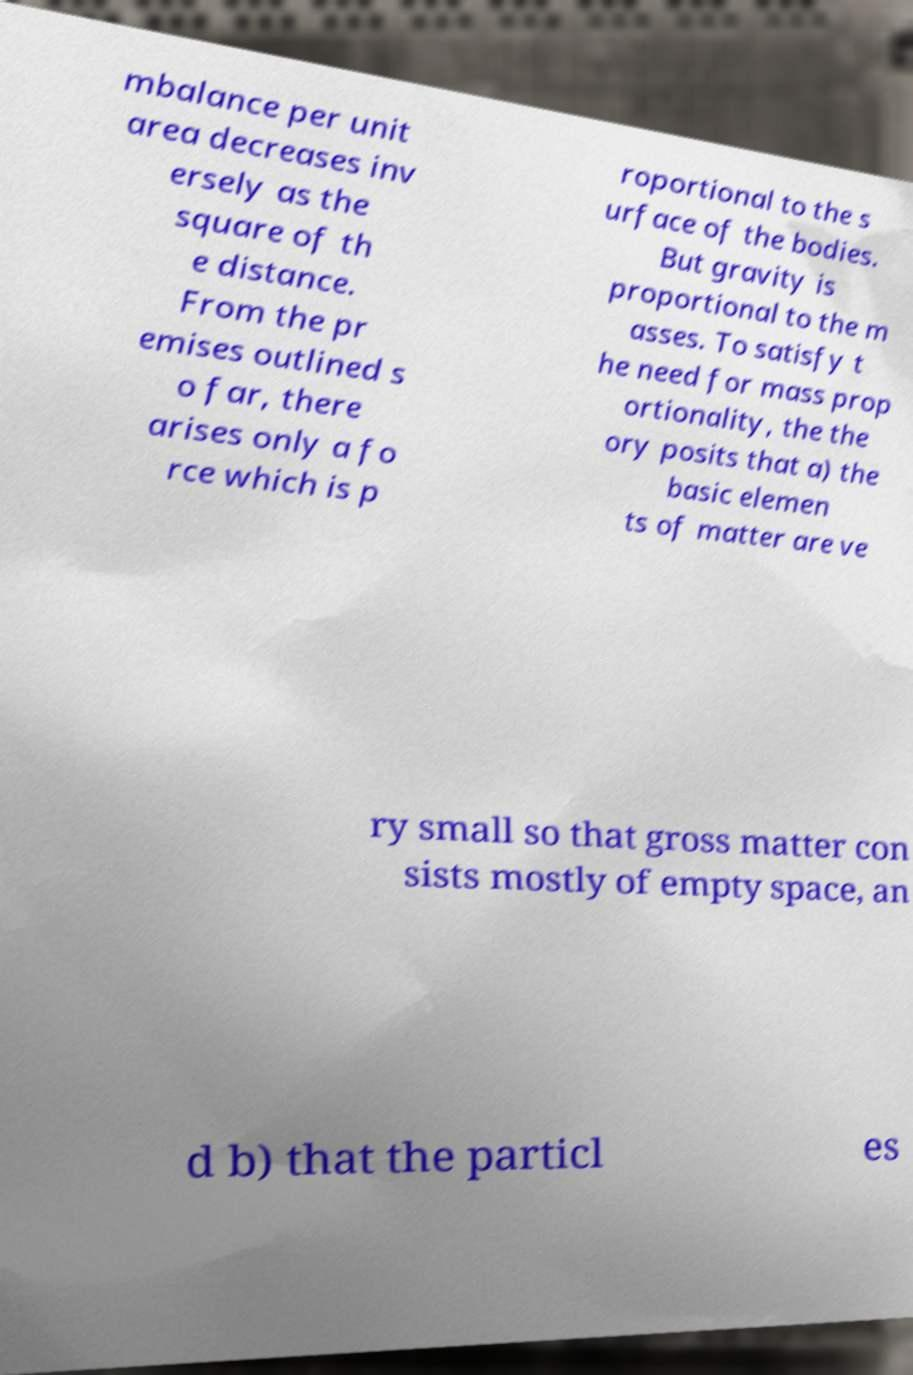What messages or text are displayed in this image? I need them in a readable, typed format. mbalance per unit area decreases inv ersely as the square of th e distance. From the pr emises outlined s o far, there arises only a fo rce which is p roportional to the s urface of the bodies. But gravity is proportional to the m asses. To satisfy t he need for mass prop ortionality, the the ory posits that a) the basic elemen ts of matter are ve ry small so that gross matter con sists mostly of empty space, an d b) that the particl es 